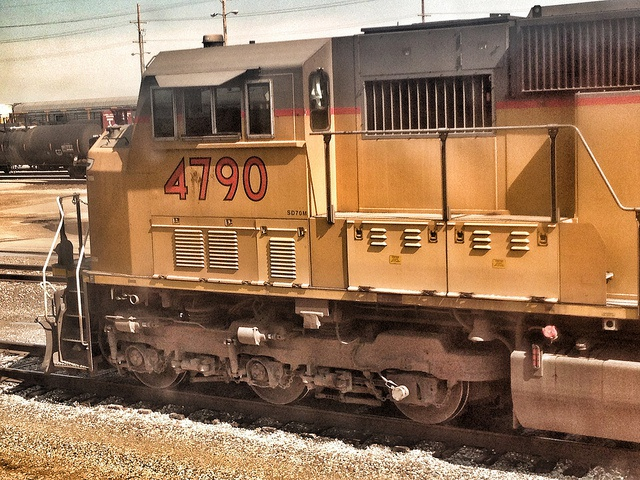Describe the objects in this image and their specific colors. I can see train in darkgray, orange, black, and gray tones and train in darkgray, gray, black, and maroon tones in this image. 